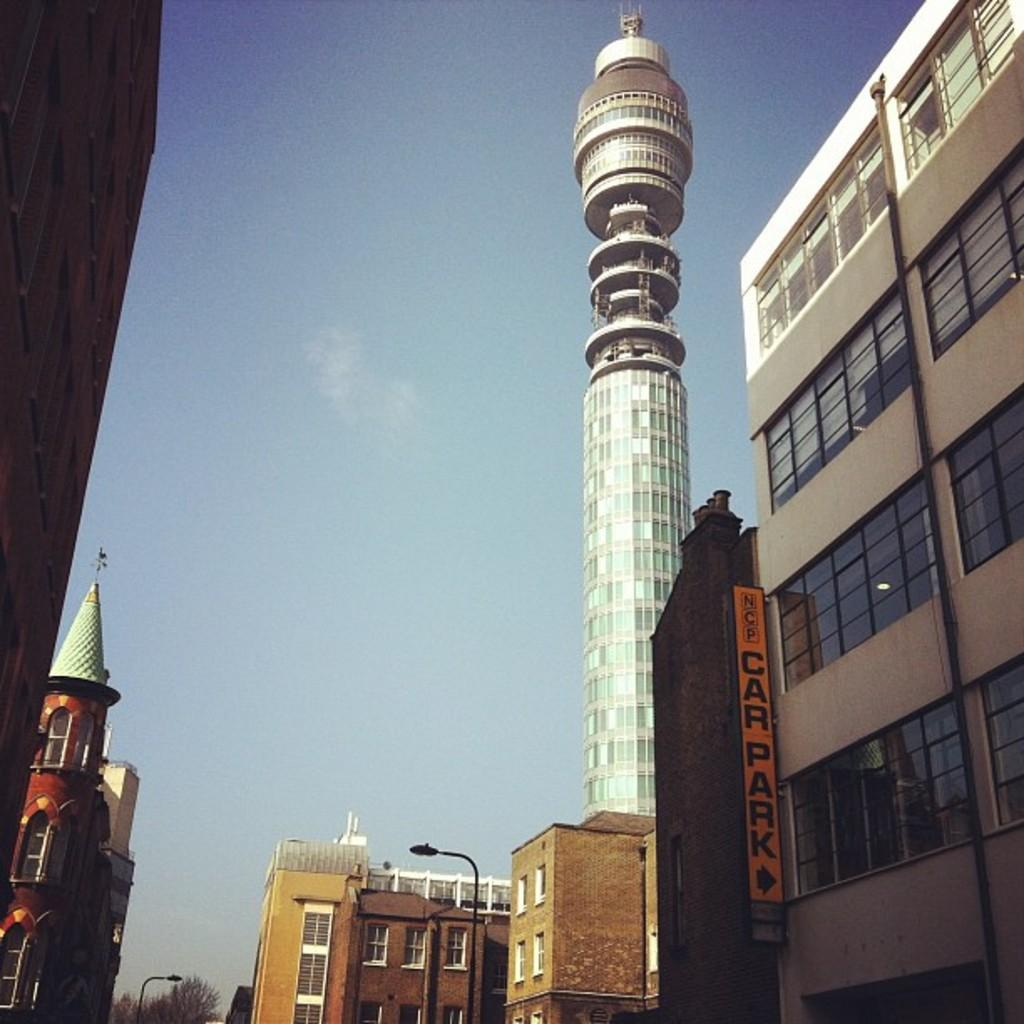What type of structures can be seen in the image? There are buildings in the image. What else can be found on the street in the image? There is a street light pole in the image. What object is present that might display information or advertisements? There is a board in the image. What type of vegetation is visible in the image? There are trees in the image. What can be seen in the distance in the image? The sky is visible in the background of the image. What type of food is being prepared on the rake in the image? There is no rake or food preparation visible in the image. What type of chain is holding the buildings together in the image? There is no chain present in the image; the buildings are standing independently. 